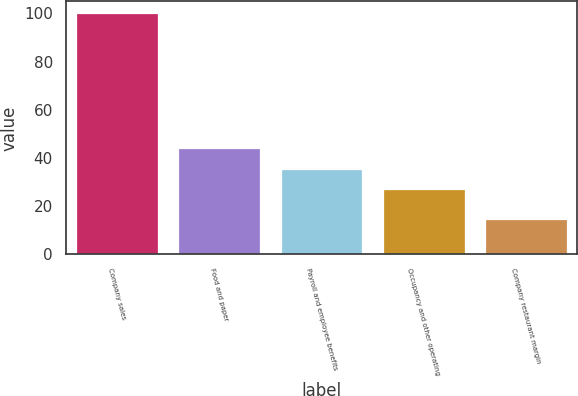Convert chart to OTSL. <chart><loc_0><loc_0><loc_500><loc_500><bar_chart><fcel>Company sales<fcel>Food and paper<fcel>Payroll and employee benefits<fcel>Occupancy and other operating<fcel>Company restaurant margin<nl><fcel>100<fcel>44.14<fcel>35.62<fcel>27.1<fcel>14.8<nl></chart> 